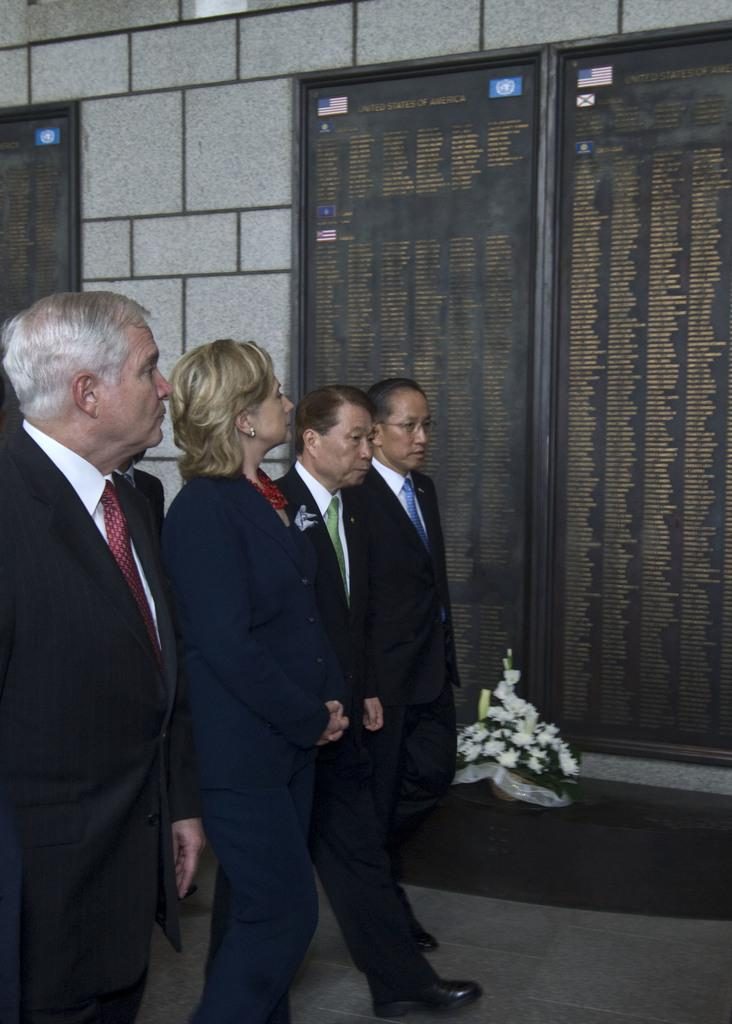What are the people in the image doing? The persons in the image are walking on the road. What can be seen in the background of the image? There is a wall, a door, and name boards in the background of the image. What type of frog can be seen hopping on the moon in the image? There is no frog or moon present in the image; it features people walking on a road with a background of a wall, door, and name boards. 